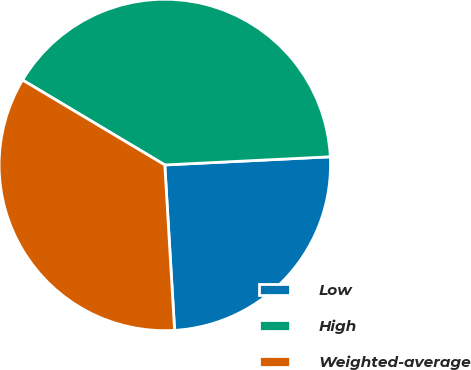<chart> <loc_0><loc_0><loc_500><loc_500><pie_chart><fcel>Low<fcel>High<fcel>Weighted-average<nl><fcel>24.84%<fcel>40.65%<fcel>34.51%<nl></chart> 